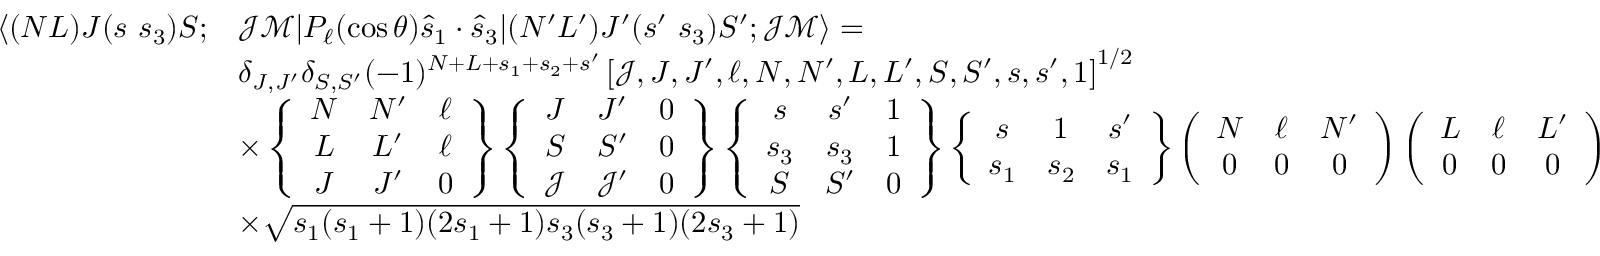<formula> <loc_0><loc_0><loc_500><loc_500>\begin{array} { r l } { \langle ( N L ) J ( s s _ { 3 } ) S ; } & { \mathcal { J } \mathcal { M } | P _ { \ell } ( \cos \theta ) \hat { s } _ { 1 } \cdot \hat { s } _ { 3 } | ( N ^ { \prime } L ^ { \prime } ) J ^ { \prime } ( s ^ { \prime } s _ { 3 } ) S ^ { \prime } ; \mathcal { J } \mathcal { M } \rangle = } \\ & { \delta _ { J , J ^ { \prime } } \delta _ { S , S ^ { \prime } } ( - 1 ) ^ { N + L + s _ { 1 } + s _ { 2 } + s ^ { \prime } } \left [ \mathcal { J } , J , J ^ { \prime } , \ell , N , N ^ { \prime } , L , L ^ { \prime } , S , S ^ { \prime } , s , s ^ { \prime } , 1 \right ] ^ { 1 / 2 } } \\ & { \times \left \{ \begin{array} { c c c } { N } & { N ^ { \prime } } & { \ell } \\ { L } & { L ^ { \prime } } & { \ell } \\ { J } & { J ^ { \prime } } & { 0 } \end{array} \right \} \left \{ \begin{array} { c c c } { J } & { J ^ { \prime } } & { 0 } \\ { S } & { S ^ { \prime } } & { 0 } \\ { \mathcal { J } } & { \mathcal { J } ^ { \prime } } & { 0 } \end{array} \right \} \left \{ \begin{array} { c c c } { s } & { s ^ { \prime } } & { 1 } \\ { s _ { 3 } } & { s _ { 3 } } & { 1 } \\ { S } & { S ^ { \prime } } & { 0 } \end{array} \right \} \left \{ \begin{array} { c c c } { s } & { 1 } & { s ^ { \prime } } \\ { s _ { 1 } } & { s _ { 2 } } & { s _ { 1 } } \end{array} \right \} \left ( \begin{array} { c c c } { N } & { \ell } & { N ^ { \prime } } \\ { 0 } & { 0 } & { 0 } \end{array} \right ) \left ( \begin{array} { c c c } { L } & { \ell } & { L ^ { \prime } } \\ { 0 } & { 0 } & { 0 } \end{array} \right ) } \\ & { \times \sqrt { s _ { 1 } ( s _ { 1 } + 1 ) ( 2 s _ { 1 } + 1 ) s _ { 3 } ( s _ { 3 } + 1 ) ( 2 s _ { 3 } + 1 ) } } \end{array}</formula> 